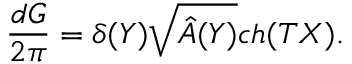<formula> <loc_0><loc_0><loc_500><loc_500>{ \frac { d G } { 2 \pi } } = \delta ( Y ) \sqrt { \hat { A } ( Y ) } c h ( T X ) .</formula> 